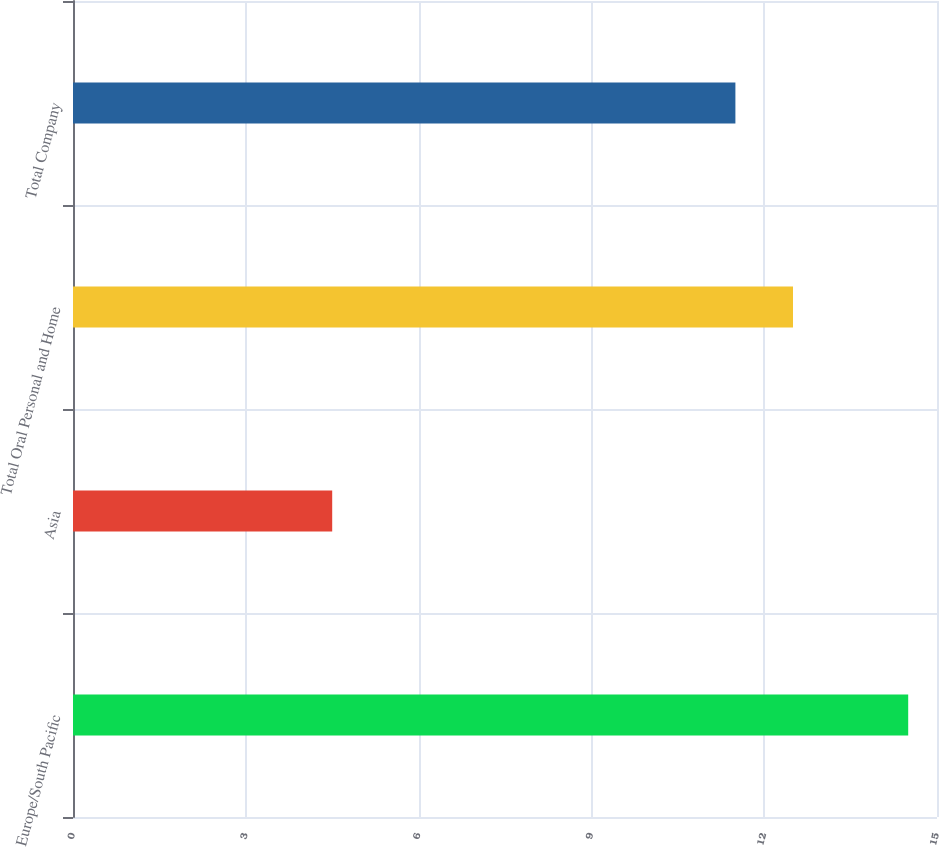Convert chart. <chart><loc_0><loc_0><loc_500><loc_500><bar_chart><fcel>Europe/South Pacific<fcel>Asia<fcel>Total Oral Personal and Home<fcel>Total Company<nl><fcel>14.5<fcel>4.5<fcel>12.5<fcel>11.5<nl></chart> 